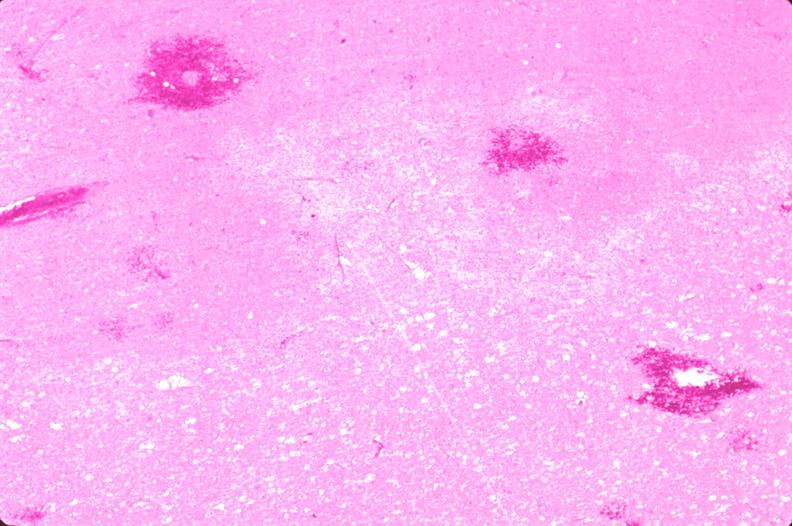where is this?
Answer the question using a single word or phrase. Nervous 